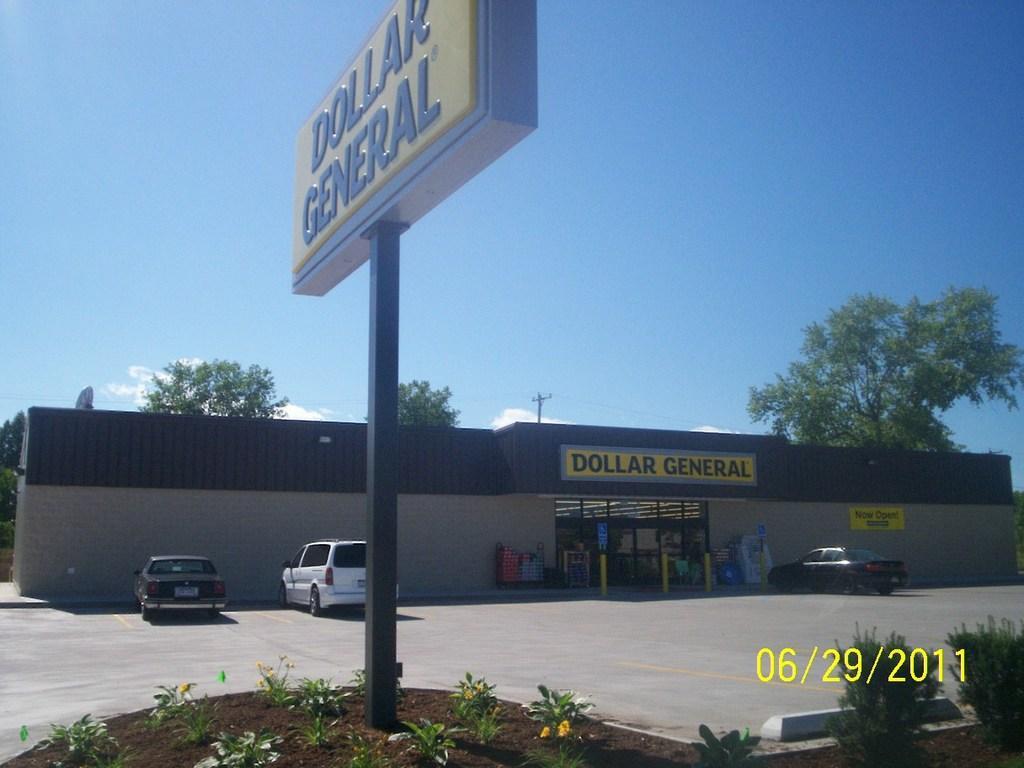Can you describe this image briefly? In this picture there is a building and there is a text on the wall. There are vehicles on the road. In the foreground there is a board on the pole and there is a text on the board and there are plants. At back there are trees and there is a pole. At the top there is sky and there are clouds. 